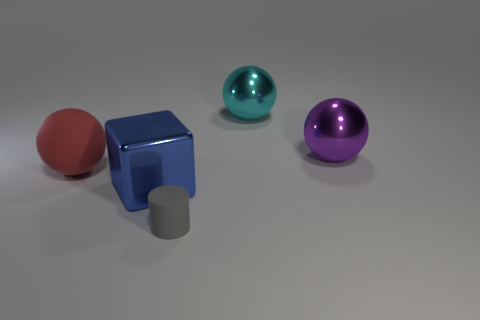How big is the rubber object that is left of the big shiny thing in front of the large sphere left of the metallic cube?
Give a very brief answer. Large. What number of things are in front of the sphere that is to the left of the cyan thing?
Offer a terse response. 2. How big is the object that is both on the left side of the small gray rubber thing and in front of the big red thing?
Make the answer very short. Large. How many metallic objects are small cylinders or small brown cubes?
Provide a short and direct response. 0. What is the material of the blue cube?
Your response must be concise. Metal. There is a thing in front of the big shiny block that is to the right of the matte object that is behind the blue shiny object; what is it made of?
Your answer should be compact. Rubber. What shape is the blue object that is the same size as the purple metallic thing?
Provide a short and direct response. Cube. How many things are either big red balls or large things to the left of the large cyan shiny sphere?
Your response must be concise. 2. Do the purple ball behind the gray thing and the object behind the purple metal ball have the same material?
Provide a succinct answer. Yes. How many blue things are metallic cubes or big rubber spheres?
Keep it short and to the point. 1. 